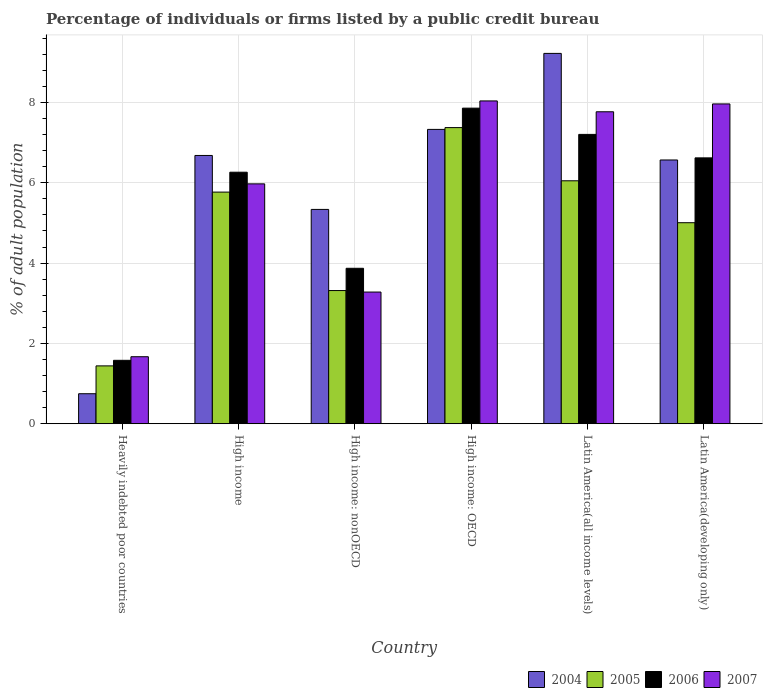How many groups of bars are there?
Provide a short and direct response. 6. Are the number of bars per tick equal to the number of legend labels?
Offer a terse response. Yes. What is the label of the 3rd group of bars from the left?
Give a very brief answer. High income: nonOECD. In how many cases, is the number of bars for a given country not equal to the number of legend labels?
Your answer should be very brief. 0. What is the percentage of population listed by a public credit bureau in 2004 in Heavily indebted poor countries?
Ensure brevity in your answer.  0.75. Across all countries, what is the maximum percentage of population listed by a public credit bureau in 2004?
Provide a succinct answer. 9.22. Across all countries, what is the minimum percentage of population listed by a public credit bureau in 2005?
Offer a terse response. 1.44. In which country was the percentage of population listed by a public credit bureau in 2004 maximum?
Your answer should be compact. Latin America(all income levels). In which country was the percentage of population listed by a public credit bureau in 2005 minimum?
Your answer should be very brief. Heavily indebted poor countries. What is the total percentage of population listed by a public credit bureau in 2005 in the graph?
Your answer should be very brief. 28.95. What is the difference between the percentage of population listed by a public credit bureau in 2005 in High income and that in Latin America(developing only)?
Offer a terse response. 0.76. What is the difference between the percentage of population listed by a public credit bureau in 2004 in High income: nonOECD and the percentage of population listed by a public credit bureau in 2007 in Heavily indebted poor countries?
Your answer should be compact. 3.67. What is the average percentage of population listed by a public credit bureau in 2004 per country?
Give a very brief answer. 5.98. What is the difference between the percentage of population listed by a public credit bureau of/in 2004 and percentage of population listed by a public credit bureau of/in 2007 in High income: OECD?
Your answer should be very brief. -0.71. In how many countries, is the percentage of population listed by a public credit bureau in 2007 greater than 4.4 %?
Give a very brief answer. 4. What is the ratio of the percentage of population listed by a public credit bureau in 2007 in Heavily indebted poor countries to that in High income: OECD?
Provide a succinct answer. 0.21. Is the percentage of population listed by a public credit bureau in 2005 in High income: OECD less than that in Latin America(all income levels)?
Ensure brevity in your answer.  No. Is the difference between the percentage of population listed by a public credit bureau in 2004 in Heavily indebted poor countries and High income: OECD greater than the difference between the percentage of population listed by a public credit bureau in 2007 in Heavily indebted poor countries and High income: OECD?
Ensure brevity in your answer.  No. What is the difference between the highest and the second highest percentage of population listed by a public credit bureau in 2007?
Your response must be concise. 0.27. What is the difference between the highest and the lowest percentage of population listed by a public credit bureau in 2005?
Your answer should be very brief. 5.93. What does the 2nd bar from the left in Latin America(all income levels) represents?
Provide a succinct answer. 2005. How many bars are there?
Ensure brevity in your answer.  24. How many countries are there in the graph?
Offer a very short reply. 6. Are the values on the major ticks of Y-axis written in scientific E-notation?
Your answer should be compact. No. Where does the legend appear in the graph?
Offer a very short reply. Bottom right. How are the legend labels stacked?
Keep it short and to the point. Horizontal. What is the title of the graph?
Your response must be concise. Percentage of individuals or firms listed by a public credit bureau. What is the label or title of the X-axis?
Your response must be concise. Country. What is the label or title of the Y-axis?
Give a very brief answer. % of adult population. What is the % of adult population of 2004 in Heavily indebted poor countries?
Give a very brief answer. 0.75. What is the % of adult population of 2005 in Heavily indebted poor countries?
Offer a terse response. 1.44. What is the % of adult population of 2006 in Heavily indebted poor countries?
Your answer should be very brief. 1.58. What is the % of adult population of 2007 in Heavily indebted poor countries?
Offer a very short reply. 1.67. What is the % of adult population of 2004 in High income?
Keep it short and to the point. 6.68. What is the % of adult population in 2005 in High income?
Your response must be concise. 5.77. What is the % of adult population in 2006 in High income?
Your answer should be very brief. 6.26. What is the % of adult population of 2007 in High income?
Your answer should be very brief. 5.97. What is the % of adult population of 2004 in High income: nonOECD?
Provide a succinct answer. 5.34. What is the % of adult population in 2005 in High income: nonOECD?
Provide a succinct answer. 3.32. What is the % of adult population in 2006 in High income: nonOECD?
Offer a very short reply. 3.87. What is the % of adult population in 2007 in High income: nonOECD?
Your response must be concise. 3.28. What is the % of adult population of 2004 in High income: OECD?
Your response must be concise. 7.33. What is the % of adult population in 2005 in High income: OECD?
Your answer should be very brief. 7.37. What is the % of adult population of 2006 in High income: OECD?
Provide a succinct answer. 7.86. What is the % of adult population of 2007 in High income: OECD?
Ensure brevity in your answer.  8.04. What is the % of adult population of 2004 in Latin America(all income levels)?
Give a very brief answer. 9.22. What is the % of adult population of 2005 in Latin America(all income levels)?
Offer a terse response. 6.05. What is the % of adult population of 2006 in Latin America(all income levels)?
Your response must be concise. 7.2. What is the % of adult population in 2007 in Latin America(all income levels)?
Provide a succinct answer. 7.77. What is the % of adult population of 2004 in Latin America(developing only)?
Offer a terse response. 6.57. What is the % of adult population of 2005 in Latin America(developing only)?
Your response must be concise. 5. What is the % of adult population in 2006 in Latin America(developing only)?
Your response must be concise. 6.62. What is the % of adult population in 2007 in Latin America(developing only)?
Your answer should be very brief. 7.96. Across all countries, what is the maximum % of adult population of 2004?
Ensure brevity in your answer.  9.22. Across all countries, what is the maximum % of adult population in 2005?
Provide a short and direct response. 7.37. Across all countries, what is the maximum % of adult population of 2006?
Provide a succinct answer. 7.86. Across all countries, what is the maximum % of adult population of 2007?
Provide a short and direct response. 8.04. Across all countries, what is the minimum % of adult population of 2004?
Ensure brevity in your answer.  0.75. Across all countries, what is the minimum % of adult population of 2005?
Your answer should be very brief. 1.44. Across all countries, what is the minimum % of adult population of 2006?
Your answer should be compact. 1.58. Across all countries, what is the minimum % of adult population in 2007?
Keep it short and to the point. 1.67. What is the total % of adult population of 2004 in the graph?
Give a very brief answer. 35.88. What is the total % of adult population in 2005 in the graph?
Provide a short and direct response. 28.95. What is the total % of adult population of 2006 in the graph?
Offer a terse response. 33.39. What is the total % of adult population in 2007 in the graph?
Offer a very short reply. 34.68. What is the difference between the % of adult population in 2004 in Heavily indebted poor countries and that in High income?
Ensure brevity in your answer.  -5.93. What is the difference between the % of adult population of 2005 in Heavily indebted poor countries and that in High income?
Your answer should be very brief. -4.33. What is the difference between the % of adult population in 2006 in Heavily indebted poor countries and that in High income?
Provide a short and direct response. -4.68. What is the difference between the % of adult population of 2007 in Heavily indebted poor countries and that in High income?
Your response must be concise. -4.3. What is the difference between the % of adult population in 2004 in Heavily indebted poor countries and that in High income: nonOECD?
Provide a succinct answer. -4.59. What is the difference between the % of adult population in 2005 in Heavily indebted poor countries and that in High income: nonOECD?
Provide a succinct answer. -1.88. What is the difference between the % of adult population of 2006 in Heavily indebted poor countries and that in High income: nonOECD?
Your response must be concise. -2.29. What is the difference between the % of adult population of 2007 in Heavily indebted poor countries and that in High income: nonOECD?
Ensure brevity in your answer.  -1.61. What is the difference between the % of adult population of 2004 in Heavily indebted poor countries and that in High income: OECD?
Keep it short and to the point. -6.58. What is the difference between the % of adult population in 2005 in Heavily indebted poor countries and that in High income: OECD?
Offer a very short reply. -5.93. What is the difference between the % of adult population of 2006 in Heavily indebted poor countries and that in High income: OECD?
Give a very brief answer. -6.28. What is the difference between the % of adult population in 2007 in Heavily indebted poor countries and that in High income: OECD?
Give a very brief answer. -6.37. What is the difference between the % of adult population of 2004 in Heavily indebted poor countries and that in Latin America(all income levels)?
Make the answer very short. -8.47. What is the difference between the % of adult population in 2005 in Heavily indebted poor countries and that in Latin America(all income levels)?
Give a very brief answer. -4.61. What is the difference between the % of adult population in 2006 in Heavily indebted poor countries and that in Latin America(all income levels)?
Your answer should be compact. -5.62. What is the difference between the % of adult population in 2007 in Heavily indebted poor countries and that in Latin America(all income levels)?
Offer a very short reply. -6.1. What is the difference between the % of adult population in 2004 in Heavily indebted poor countries and that in Latin America(developing only)?
Provide a succinct answer. -5.82. What is the difference between the % of adult population in 2005 in Heavily indebted poor countries and that in Latin America(developing only)?
Make the answer very short. -3.56. What is the difference between the % of adult population in 2006 in Heavily indebted poor countries and that in Latin America(developing only)?
Keep it short and to the point. -5.04. What is the difference between the % of adult population of 2007 in Heavily indebted poor countries and that in Latin America(developing only)?
Your answer should be compact. -6.29. What is the difference between the % of adult population in 2004 in High income and that in High income: nonOECD?
Ensure brevity in your answer.  1.34. What is the difference between the % of adult population of 2005 in High income and that in High income: nonOECD?
Your answer should be very brief. 2.45. What is the difference between the % of adult population in 2006 in High income and that in High income: nonOECD?
Provide a succinct answer. 2.39. What is the difference between the % of adult population of 2007 in High income and that in High income: nonOECD?
Make the answer very short. 2.69. What is the difference between the % of adult population of 2004 in High income and that in High income: OECD?
Offer a very short reply. -0.65. What is the difference between the % of adult population in 2005 in High income and that in High income: OECD?
Provide a short and direct response. -1.61. What is the difference between the % of adult population of 2006 in High income and that in High income: OECD?
Give a very brief answer. -1.59. What is the difference between the % of adult population of 2007 in High income and that in High income: OECD?
Ensure brevity in your answer.  -2.06. What is the difference between the % of adult population in 2004 in High income and that in Latin America(all income levels)?
Keep it short and to the point. -2.54. What is the difference between the % of adult population in 2005 in High income and that in Latin America(all income levels)?
Give a very brief answer. -0.28. What is the difference between the % of adult population in 2006 in High income and that in Latin America(all income levels)?
Make the answer very short. -0.94. What is the difference between the % of adult population of 2007 in High income and that in Latin America(all income levels)?
Keep it short and to the point. -1.79. What is the difference between the % of adult population of 2004 in High income and that in Latin America(developing only)?
Provide a short and direct response. 0.11. What is the difference between the % of adult population in 2005 in High income and that in Latin America(developing only)?
Offer a very short reply. 0.76. What is the difference between the % of adult population of 2006 in High income and that in Latin America(developing only)?
Offer a very short reply. -0.36. What is the difference between the % of adult population of 2007 in High income and that in Latin America(developing only)?
Your response must be concise. -1.99. What is the difference between the % of adult population of 2004 in High income: nonOECD and that in High income: OECD?
Your response must be concise. -1.99. What is the difference between the % of adult population of 2005 in High income: nonOECD and that in High income: OECD?
Your response must be concise. -4.06. What is the difference between the % of adult population of 2006 in High income: nonOECD and that in High income: OECD?
Your answer should be compact. -3.99. What is the difference between the % of adult population in 2007 in High income: nonOECD and that in High income: OECD?
Offer a very short reply. -4.76. What is the difference between the % of adult population of 2004 in High income: nonOECD and that in Latin America(all income levels)?
Your answer should be compact. -3.88. What is the difference between the % of adult population of 2005 in High income: nonOECD and that in Latin America(all income levels)?
Offer a terse response. -2.73. What is the difference between the % of adult population of 2006 in High income: nonOECD and that in Latin America(all income levels)?
Provide a short and direct response. -3.33. What is the difference between the % of adult population in 2007 in High income: nonOECD and that in Latin America(all income levels)?
Offer a very short reply. -4.49. What is the difference between the % of adult population in 2004 in High income: nonOECD and that in Latin America(developing only)?
Keep it short and to the point. -1.23. What is the difference between the % of adult population of 2005 in High income: nonOECD and that in Latin America(developing only)?
Keep it short and to the point. -1.69. What is the difference between the % of adult population in 2006 in High income: nonOECD and that in Latin America(developing only)?
Keep it short and to the point. -2.75. What is the difference between the % of adult population in 2007 in High income: nonOECD and that in Latin America(developing only)?
Provide a succinct answer. -4.68. What is the difference between the % of adult population of 2004 in High income: OECD and that in Latin America(all income levels)?
Your answer should be compact. -1.89. What is the difference between the % of adult population in 2005 in High income: OECD and that in Latin America(all income levels)?
Give a very brief answer. 1.32. What is the difference between the % of adult population in 2006 in High income: OECD and that in Latin America(all income levels)?
Provide a succinct answer. 0.65. What is the difference between the % of adult population of 2007 in High income: OECD and that in Latin America(all income levels)?
Give a very brief answer. 0.27. What is the difference between the % of adult population of 2004 in High income: OECD and that in Latin America(developing only)?
Your answer should be compact. 0.76. What is the difference between the % of adult population in 2005 in High income: OECD and that in Latin America(developing only)?
Your answer should be compact. 2.37. What is the difference between the % of adult population of 2006 in High income: OECD and that in Latin America(developing only)?
Your answer should be compact. 1.24. What is the difference between the % of adult population in 2007 in High income: OECD and that in Latin America(developing only)?
Your answer should be compact. 0.07. What is the difference between the % of adult population of 2004 in Latin America(all income levels) and that in Latin America(developing only)?
Your answer should be very brief. 2.65. What is the difference between the % of adult population in 2005 in Latin America(all income levels) and that in Latin America(developing only)?
Offer a very short reply. 1.04. What is the difference between the % of adult population of 2006 in Latin America(all income levels) and that in Latin America(developing only)?
Ensure brevity in your answer.  0.58. What is the difference between the % of adult population in 2007 in Latin America(all income levels) and that in Latin America(developing only)?
Offer a terse response. -0.2. What is the difference between the % of adult population in 2004 in Heavily indebted poor countries and the % of adult population in 2005 in High income?
Offer a very short reply. -5.02. What is the difference between the % of adult population of 2004 in Heavily indebted poor countries and the % of adult population of 2006 in High income?
Keep it short and to the point. -5.51. What is the difference between the % of adult population in 2004 in Heavily indebted poor countries and the % of adult population in 2007 in High income?
Provide a succinct answer. -5.22. What is the difference between the % of adult population of 2005 in Heavily indebted poor countries and the % of adult population of 2006 in High income?
Your answer should be very brief. -4.82. What is the difference between the % of adult population in 2005 in Heavily indebted poor countries and the % of adult population in 2007 in High income?
Ensure brevity in your answer.  -4.53. What is the difference between the % of adult population in 2006 in Heavily indebted poor countries and the % of adult population in 2007 in High income?
Give a very brief answer. -4.39. What is the difference between the % of adult population in 2004 in Heavily indebted poor countries and the % of adult population in 2005 in High income: nonOECD?
Your response must be concise. -2.57. What is the difference between the % of adult population of 2004 in Heavily indebted poor countries and the % of adult population of 2006 in High income: nonOECD?
Give a very brief answer. -3.12. What is the difference between the % of adult population in 2004 in Heavily indebted poor countries and the % of adult population in 2007 in High income: nonOECD?
Provide a short and direct response. -2.53. What is the difference between the % of adult population of 2005 in Heavily indebted poor countries and the % of adult population of 2006 in High income: nonOECD?
Keep it short and to the point. -2.43. What is the difference between the % of adult population of 2005 in Heavily indebted poor countries and the % of adult population of 2007 in High income: nonOECD?
Offer a very short reply. -1.84. What is the difference between the % of adult population of 2006 in Heavily indebted poor countries and the % of adult population of 2007 in High income: nonOECD?
Provide a short and direct response. -1.7. What is the difference between the % of adult population of 2004 in Heavily indebted poor countries and the % of adult population of 2005 in High income: OECD?
Provide a succinct answer. -6.63. What is the difference between the % of adult population of 2004 in Heavily indebted poor countries and the % of adult population of 2006 in High income: OECD?
Your response must be concise. -7.11. What is the difference between the % of adult population of 2004 in Heavily indebted poor countries and the % of adult population of 2007 in High income: OECD?
Make the answer very short. -7.29. What is the difference between the % of adult population of 2005 in Heavily indebted poor countries and the % of adult population of 2006 in High income: OECD?
Your answer should be compact. -6.42. What is the difference between the % of adult population of 2005 in Heavily indebted poor countries and the % of adult population of 2007 in High income: OECD?
Keep it short and to the point. -6.6. What is the difference between the % of adult population in 2006 in Heavily indebted poor countries and the % of adult population in 2007 in High income: OECD?
Keep it short and to the point. -6.46. What is the difference between the % of adult population of 2004 in Heavily indebted poor countries and the % of adult population of 2005 in Latin America(all income levels)?
Make the answer very short. -5.3. What is the difference between the % of adult population of 2004 in Heavily indebted poor countries and the % of adult population of 2006 in Latin America(all income levels)?
Offer a very short reply. -6.46. What is the difference between the % of adult population of 2004 in Heavily indebted poor countries and the % of adult population of 2007 in Latin America(all income levels)?
Keep it short and to the point. -7.02. What is the difference between the % of adult population in 2005 in Heavily indebted poor countries and the % of adult population in 2006 in Latin America(all income levels)?
Offer a very short reply. -5.76. What is the difference between the % of adult population in 2005 in Heavily indebted poor countries and the % of adult population in 2007 in Latin America(all income levels)?
Give a very brief answer. -6.33. What is the difference between the % of adult population in 2006 in Heavily indebted poor countries and the % of adult population in 2007 in Latin America(all income levels)?
Your response must be concise. -6.19. What is the difference between the % of adult population in 2004 in Heavily indebted poor countries and the % of adult population in 2005 in Latin America(developing only)?
Your answer should be compact. -4.26. What is the difference between the % of adult population in 2004 in Heavily indebted poor countries and the % of adult population in 2006 in Latin America(developing only)?
Offer a terse response. -5.87. What is the difference between the % of adult population of 2004 in Heavily indebted poor countries and the % of adult population of 2007 in Latin America(developing only)?
Provide a short and direct response. -7.21. What is the difference between the % of adult population of 2005 in Heavily indebted poor countries and the % of adult population of 2006 in Latin America(developing only)?
Your answer should be compact. -5.18. What is the difference between the % of adult population in 2005 in Heavily indebted poor countries and the % of adult population in 2007 in Latin America(developing only)?
Ensure brevity in your answer.  -6.52. What is the difference between the % of adult population of 2006 in Heavily indebted poor countries and the % of adult population of 2007 in Latin America(developing only)?
Make the answer very short. -6.38. What is the difference between the % of adult population of 2004 in High income and the % of adult population of 2005 in High income: nonOECD?
Offer a terse response. 3.36. What is the difference between the % of adult population in 2004 in High income and the % of adult population in 2006 in High income: nonOECD?
Ensure brevity in your answer.  2.81. What is the difference between the % of adult population of 2004 in High income and the % of adult population of 2007 in High income: nonOECD?
Ensure brevity in your answer.  3.4. What is the difference between the % of adult population of 2005 in High income and the % of adult population of 2006 in High income: nonOECD?
Your answer should be compact. 1.9. What is the difference between the % of adult population in 2005 in High income and the % of adult population in 2007 in High income: nonOECD?
Your answer should be compact. 2.49. What is the difference between the % of adult population in 2006 in High income and the % of adult population in 2007 in High income: nonOECD?
Offer a very short reply. 2.98. What is the difference between the % of adult population in 2004 in High income and the % of adult population in 2005 in High income: OECD?
Offer a very short reply. -0.69. What is the difference between the % of adult population of 2004 in High income and the % of adult population of 2006 in High income: OECD?
Your answer should be compact. -1.18. What is the difference between the % of adult population of 2004 in High income and the % of adult population of 2007 in High income: OECD?
Give a very brief answer. -1.36. What is the difference between the % of adult population of 2005 in High income and the % of adult population of 2006 in High income: OECD?
Make the answer very short. -2.09. What is the difference between the % of adult population in 2005 in High income and the % of adult population in 2007 in High income: OECD?
Offer a very short reply. -2.27. What is the difference between the % of adult population of 2006 in High income and the % of adult population of 2007 in High income: OECD?
Offer a terse response. -1.77. What is the difference between the % of adult population in 2004 in High income and the % of adult population in 2005 in Latin America(all income levels)?
Your answer should be very brief. 0.63. What is the difference between the % of adult population of 2004 in High income and the % of adult population of 2006 in Latin America(all income levels)?
Give a very brief answer. -0.52. What is the difference between the % of adult population of 2004 in High income and the % of adult population of 2007 in Latin America(all income levels)?
Provide a succinct answer. -1.09. What is the difference between the % of adult population of 2005 in High income and the % of adult population of 2006 in Latin America(all income levels)?
Your answer should be compact. -1.44. What is the difference between the % of adult population of 2006 in High income and the % of adult population of 2007 in Latin America(all income levels)?
Your response must be concise. -1.5. What is the difference between the % of adult population in 2004 in High income and the % of adult population in 2005 in Latin America(developing only)?
Offer a terse response. 1.67. What is the difference between the % of adult population in 2004 in High income and the % of adult population in 2006 in Latin America(developing only)?
Provide a succinct answer. 0.06. What is the difference between the % of adult population in 2004 in High income and the % of adult population in 2007 in Latin America(developing only)?
Make the answer very short. -1.28. What is the difference between the % of adult population of 2005 in High income and the % of adult population of 2006 in Latin America(developing only)?
Offer a very short reply. -0.85. What is the difference between the % of adult population in 2005 in High income and the % of adult population in 2007 in Latin America(developing only)?
Ensure brevity in your answer.  -2.2. What is the difference between the % of adult population of 2006 in High income and the % of adult population of 2007 in Latin America(developing only)?
Offer a terse response. -1.7. What is the difference between the % of adult population of 2004 in High income: nonOECD and the % of adult population of 2005 in High income: OECD?
Offer a very short reply. -2.04. What is the difference between the % of adult population of 2004 in High income: nonOECD and the % of adult population of 2006 in High income: OECD?
Provide a short and direct response. -2.52. What is the difference between the % of adult population in 2004 in High income: nonOECD and the % of adult population in 2007 in High income: OECD?
Give a very brief answer. -2.7. What is the difference between the % of adult population of 2005 in High income: nonOECD and the % of adult population of 2006 in High income: OECD?
Make the answer very short. -4.54. What is the difference between the % of adult population of 2005 in High income: nonOECD and the % of adult population of 2007 in High income: OECD?
Keep it short and to the point. -4.72. What is the difference between the % of adult population of 2006 in High income: nonOECD and the % of adult population of 2007 in High income: OECD?
Your answer should be very brief. -4.17. What is the difference between the % of adult population of 2004 in High income: nonOECD and the % of adult population of 2005 in Latin America(all income levels)?
Provide a short and direct response. -0.71. What is the difference between the % of adult population in 2004 in High income: nonOECD and the % of adult population in 2006 in Latin America(all income levels)?
Provide a succinct answer. -1.87. What is the difference between the % of adult population in 2004 in High income: nonOECD and the % of adult population in 2007 in Latin America(all income levels)?
Your response must be concise. -2.43. What is the difference between the % of adult population in 2005 in High income: nonOECD and the % of adult population in 2006 in Latin America(all income levels)?
Provide a succinct answer. -3.89. What is the difference between the % of adult population of 2005 in High income: nonOECD and the % of adult population of 2007 in Latin America(all income levels)?
Make the answer very short. -4.45. What is the difference between the % of adult population in 2006 in High income: nonOECD and the % of adult population in 2007 in Latin America(all income levels)?
Make the answer very short. -3.9. What is the difference between the % of adult population of 2004 in High income: nonOECD and the % of adult population of 2005 in Latin America(developing only)?
Your answer should be compact. 0.33. What is the difference between the % of adult population of 2004 in High income: nonOECD and the % of adult population of 2006 in Latin America(developing only)?
Keep it short and to the point. -1.28. What is the difference between the % of adult population in 2004 in High income: nonOECD and the % of adult population in 2007 in Latin America(developing only)?
Offer a terse response. -2.63. What is the difference between the % of adult population of 2005 in High income: nonOECD and the % of adult population of 2006 in Latin America(developing only)?
Provide a short and direct response. -3.3. What is the difference between the % of adult population in 2005 in High income: nonOECD and the % of adult population in 2007 in Latin America(developing only)?
Provide a succinct answer. -4.65. What is the difference between the % of adult population in 2006 in High income: nonOECD and the % of adult population in 2007 in Latin America(developing only)?
Keep it short and to the point. -4.09. What is the difference between the % of adult population of 2004 in High income: OECD and the % of adult population of 2005 in Latin America(all income levels)?
Provide a short and direct response. 1.28. What is the difference between the % of adult population in 2004 in High income: OECD and the % of adult population in 2006 in Latin America(all income levels)?
Provide a short and direct response. 0.12. What is the difference between the % of adult population in 2004 in High income: OECD and the % of adult population in 2007 in Latin America(all income levels)?
Offer a very short reply. -0.44. What is the difference between the % of adult population of 2005 in High income: OECD and the % of adult population of 2006 in Latin America(all income levels)?
Ensure brevity in your answer.  0.17. What is the difference between the % of adult population in 2005 in High income: OECD and the % of adult population in 2007 in Latin America(all income levels)?
Make the answer very short. -0.39. What is the difference between the % of adult population of 2006 in High income: OECD and the % of adult population of 2007 in Latin America(all income levels)?
Keep it short and to the point. 0.09. What is the difference between the % of adult population in 2004 in High income: OECD and the % of adult population in 2005 in Latin America(developing only)?
Keep it short and to the point. 2.32. What is the difference between the % of adult population of 2004 in High income: OECD and the % of adult population of 2006 in Latin America(developing only)?
Give a very brief answer. 0.71. What is the difference between the % of adult population in 2004 in High income: OECD and the % of adult population in 2007 in Latin America(developing only)?
Provide a short and direct response. -0.63. What is the difference between the % of adult population of 2005 in High income: OECD and the % of adult population of 2006 in Latin America(developing only)?
Your response must be concise. 0.75. What is the difference between the % of adult population in 2005 in High income: OECD and the % of adult population in 2007 in Latin America(developing only)?
Give a very brief answer. -0.59. What is the difference between the % of adult population of 2006 in High income: OECD and the % of adult population of 2007 in Latin America(developing only)?
Give a very brief answer. -0.11. What is the difference between the % of adult population in 2004 in Latin America(all income levels) and the % of adult population in 2005 in Latin America(developing only)?
Your answer should be very brief. 4.22. What is the difference between the % of adult population of 2004 in Latin America(all income levels) and the % of adult population of 2006 in Latin America(developing only)?
Keep it short and to the point. 2.6. What is the difference between the % of adult population in 2004 in Latin America(all income levels) and the % of adult population in 2007 in Latin America(developing only)?
Ensure brevity in your answer.  1.26. What is the difference between the % of adult population in 2005 in Latin America(all income levels) and the % of adult population in 2006 in Latin America(developing only)?
Your response must be concise. -0.57. What is the difference between the % of adult population in 2005 in Latin America(all income levels) and the % of adult population in 2007 in Latin America(developing only)?
Make the answer very short. -1.91. What is the difference between the % of adult population of 2006 in Latin America(all income levels) and the % of adult population of 2007 in Latin America(developing only)?
Your answer should be compact. -0.76. What is the average % of adult population of 2004 per country?
Provide a succinct answer. 5.98. What is the average % of adult population in 2005 per country?
Offer a very short reply. 4.82. What is the average % of adult population of 2006 per country?
Make the answer very short. 5.57. What is the average % of adult population of 2007 per country?
Ensure brevity in your answer.  5.78. What is the difference between the % of adult population of 2004 and % of adult population of 2005 in Heavily indebted poor countries?
Your response must be concise. -0.69. What is the difference between the % of adult population of 2004 and % of adult population of 2006 in Heavily indebted poor countries?
Your response must be concise. -0.83. What is the difference between the % of adult population of 2004 and % of adult population of 2007 in Heavily indebted poor countries?
Make the answer very short. -0.92. What is the difference between the % of adult population in 2005 and % of adult population in 2006 in Heavily indebted poor countries?
Offer a terse response. -0.14. What is the difference between the % of adult population in 2005 and % of adult population in 2007 in Heavily indebted poor countries?
Give a very brief answer. -0.23. What is the difference between the % of adult population in 2006 and % of adult population in 2007 in Heavily indebted poor countries?
Your response must be concise. -0.09. What is the difference between the % of adult population of 2004 and % of adult population of 2005 in High income?
Offer a very short reply. 0.91. What is the difference between the % of adult population of 2004 and % of adult population of 2006 in High income?
Your response must be concise. 0.42. What is the difference between the % of adult population in 2004 and % of adult population in 2007 in High income?
Ensure brevity in your answer.  0.71. What is the difference between the % of adult population in 2005 and % of adult population in 2006 in High income?
Provide a succinct answer. -0.5. What is the difference between the % of adult population of 2005 and % of adult population of 2007 in High income?
Offer a terse response. -0.2. What is the difference between the % of adult population of 2006 and % of adult population of 2007 in High income?
Ensure brevity in your answer.  0.29. What is the difference between the % of adult population in 2004 and % of adult population in 2005 in High income: nonOECD?
Your response must be concise. 2.02. What is the difference between the % of adult population in 2004 and % of adult population in 2006 in High income: nonOECD?
Offer a very short reply. 1.47. What is the difference between the % of adult population of 2004 and % of adult population of 2007 in High income: nonOECD?
Your response must be concise. 2.06. What is the difference between the % of adult population in 2005 and % of adult population in 2006 in High income: nonOECD?
Offer a very short reply. -0.55. What is the difference between the % of adult population in 2005 and % of adult population in 2007 in High income: nonOECD?
Keep it short and to the point. 0.04. What is the difference between the % of adult population in 2006 and % of adult population in 2007 in High income: nonOECD?
Make the answer very short. 0.59. What is the difference between the % of adult population of 2004 and % of adult population of 2005 in High income: OECD?
Ensure brevity in your answer.  -0.04. What is the difference between the % of adult population in 2004 and % of adult population in 2006 in High income: OECD?
Ensure brevity in your answer.  -0.53. What is the difference between the % of adult population in 2004 and % of adult population in 2007 in High income: OECD?
Offer a terse response. -0.71. What is the difference between the % of adult population in 2005 and % of adult population in 2006 in High income: OECD?
Your response must be concise. -0.48. What is the difference between the % of adult population in 2005 and % of adult population in 2007 in High income: OECD?
Provide a succinct answer. -0.66. What is the difference between the % of adult population in 2006 and % of adult population in 2007 in High income: OECD?
Offer a very short reply. -0.18. What is the difference between the % of adult population in 2004 and % of adult population in 2005 in Latin America(all income levels)?
Provide a short and direct response. 3.17. What is the difference between the % of adult population in 2004 and % of adult population in 2006 in Latin America(all income levels)?
Your answer should be compact. 2.02. What is the difference between the % of adult population in 2004 and % of adult population in 2007 in Latin America(all income levels)?
Make the answer very short. 1.45. What is the difference between the % of adult population in 2005 and % of adult population in 2006 in Latin America(all income levels)?
Keep it short and to the point. -1.16. What is the difference between the % of adult population of 2005 and % of adult population of 2007 in Latin America(all income levels)?
Make the answer very short. -1.72. What is the difference between the % of adult population in 2006 and % of adult population in 2007 in Latin America(all income levels)?
Give a very brief answer. -0.56. What is the difference between the % of adult population of 2004 and % of adult population of 2005 in Latin America(developing only)?
Give a very brief answer. 1.56. What is the difference between the % of adult population in 2004 and % of adult population in 2006 in Latin America(developing only)?
Offer a terse response. -0.05. What is the difference between the % of adult population in 2004 and % of adult population in 2007 in Latin America(developing only)?
Your answer should be compact. -1.4. What is the difference between the % of adult population in 2005 and % of adult population in 2006 in Latin America(developing only)?
Offer a very short reply. -1.61. What is the difference between the % of adult population of 2005 and % of adult population of 2007 in Latin America(developing only)?
Keep it short and to the point. -2.96. What is the difference between the % of adult population in 2006 and % of adult population in 2007 in Latin America(developing only)?
Your answer should be compact. -1.34. What is the ratio of the % of adult population of 2004 in Heavily indebted poor countries to that in High income?
Offer a terse response. 0.11. What is the ratio of the % of adult population of 2005 in Heavily indebted poor countries to that in High income?
Your answer should be very brief. 0.25. What is the ratio of the % of adult population of 2006 in Heavily indebted poor countries to that in High income?
Provide a succinct answer. 0.25. What is the ratio of the % of adult population of 2007 in Heavily indebted poor countries to that in High income?
Offer a very short reply. 0.28. What is the ratio of the % of adult population in 2004 in Heavily indebted poor countries to that in High income: nonOECD?
Keep it short and to the point. 0.14. What is the ratio of the % of adult population in 2005 in Heavily indebted poor countries to that in High income: nonOECD?
Provide a short and direct response. 0.43. What is the ratio of the % of adult population of 2006 in Heavily indebted poor countries to that in High income: nonOECD?
Provide a succinct answer. 0.41. What is the ratio of the % of adult population in 2007 in Heavily indebted poor countries to that in High income: nonOECD?
Your answer should be very brief. 0.51. What is the ratio of the % of adult population of 2004 in Heavily indebted poor countries to that in High income: OECD?
Your answer should be very brief. 0.1. What is the ratio of the % of adult population in 2005 in Heavily indebted poor countries to that in High income: OECD?
Your answer should be compact. 0.2. What is the ratio of the % of adult population in 2006 in Heavily indebted poor countries to that in High income: OECD?
Keep it short and to the point. 0.2. What is the ratio of the % of adult population in 2007 in Heavily indebted poor countries to that in High income: OECD?
Provide a short and direct response. 0.21. What is the ratio of the % of adult population of 2004 in Heavily indebted poor countries to that in Latin America(all income levels)?
Provide a short and direct response. 0.08. What is the ratio of the % of adult population in 2005 in Heavily indebted poor countries to that in Latin America(all income levels)?
Ensure brevity in your answer.  0.24. What is the ratio of the % of adult population in 2006 in Heavily indebted poor countries to that in Latin America(all income levels)?
Ensure brevity in your answer.  0.22. What is the ratio of the % of adult population in 2007 in Heavily indebted poor countries to that in Latin America(all income levels)?
Keep it short and to the point. 0.21. What is the ratio of the % of adult population of 2004 in Heavily indebted poor countries to that in Latin America(developing only)?
Provide a short and direct response. 0.11. What is the ratio of the % of adult population in 2005 in Heavily indebted poor countries to that in Latin America(developing only)?
Provide a short and direct response. 0.29. What is the ratio of the % of adult population of 2006 in Heavily indebted poor countries to that in Latin America(developing only)?
Your response must be concise. 0.24. What is the ratio of the % of adult population of 2007 in Heavily indebted poor countries to that in Latin America(developing only)?
Make the answer very short. 0.21. What is the ratio of the % of adult population in 2004 in High income to that in High income: nonOECD?
Ensure brevity in your answer.  1.25. What is the ratio of the % of adult population in 2005 in High income to that in High income: nonOECD?
Your answer should be compact. 1.74. What is the ratio of the % of adult population in 2006 in High income to that in High income: nonOECD?
Offer a very short reply. 1.62. What is the ratio of the % of adult population in 2007 in High income to that in High income: nonOECD?
Your answer should be compact. 1.82. What is the ratio of the % of adult population of 2004 in High income to that in High income: OECD?
Keep it short and to the point. 0.91. What is the ratio of the % of adult population of 2005 in High income to that in High income: OECD?
Make the answer very short. 0.78. What is the ratio of the % of adult population of 2006 in High income to that in High income: OECD?
Ensure brevity in your answer.  0.8. What is the ratio of the % of adult population in 2007 in High income to that in High income: OECD?
Keep it short and to the point. 0.74. What is the ratio of the % of adult population in 2004 in High income to that in Latin America(all income levels)?
Your answer should be compact. 0.72. What is the ratio of the % of adult population in 2005 in High income to that in Latin America(all income levels)?
Keep it short and to the point. 0.95. What is the ratio of the % of adult population of 2006 in High income to that in Latin America(all income levels)?
Provide a succinct answer. 0.87. What is the ratio of the % of adult population of 2007 in High income to that in Latin America(all income levels)?
Provide a short and direct response. 0.77. What is the ratio of the % of adult population of 2004 in High income to that in Latin America(developing only)?
Offer a very short reply. 1.02. What is the ratio of the % of adult population of 2005 in High income to that in Latin America(developing only)?
Keep it short and to the point. 1.15. What is the ratio of the % of adult population in 2006 in High income to that in Latin America(developing only)?
Give a very brief answer. 0.95. What is the ratio of the % of adult population of 2007 in High income to that in Latin America(developing only)?
Make the answer very short. 0.75. What is the ratio of the % of adult population in 2004 in High income: nonOECD to that in High income: OECD?
Offer a very short reply. 0.73. What is the ratio of the % of adult population of 2005 in High income: nonOECD to that in High income: OECD?
Make the answer very short. 0.45. What is the ratio of the % of adult population of 2006 in High income: nonOECD to that in High income: OECD?
Your answer should be compact. 0.49. What is the ratio of the % of adult population of 2007 in High income: nonOECD to that in High income: OECD?
Provide a short and direct response. 0.41. What is the ratio of the % of adult population in 2004 in High income: nonOECD to that in Latin America(all income levels)?
Keep it short and to the point. 0.58. What is the ratio of the % of adult population in 2005 in High income: nonOECD to that in Latin America(all income levels)?
Make the answer very short. 0.55. What is the ratio of the % of adult population in 2006 in High income: nonOECD to that in Latin America(all income levels)?
Offer a terse response. 0.54. What is the ratio of the % of adult population in 2007 in High income: nonOECD to that in Latin America(all income levels)?
Give a very brief answer. 0.42. What is the ratio of the % of adult population in 2004 in High income: nonOECD to that in Latin America(developing only)?
Your response must be concise. 0.81. What is the ratio of the % of adult population of 2005 in High income: nonOECD to that in Latin America(developing only)?
Keep it short and to the point. 0.66. What is the ratio of the % of adult population in 2006 in High income: nonOECD to that in Latin America(developing only)?
Your answer should be compact. 0.58. What is the ratio of the % of adult population of 2007 in High income: nonOECD to that in Latin America(developing only)?
Ensure brevity in your answer.  0.41. What is the ratio of the % of adult population of 2004 in High income: OECD to that in Latin America(all income levels)?
Provide a succinct answer. 0.79. What is the ratio of the % of adult population in 2005 in High income: OECD to that in Latin America(all income levels)?
Your answer should be compact. 1.22. What is the ratio of the % of adult population in 2006 in High income: OECD to that in Latin America(all income levels)?
Your answer should be compact. 1.09. What is the ratio of the % of adult population in 2007 in High income: OECD to that in Latin America(all income levels)?
Offer a very short reply. 1.03. What is the ratio of the % of adult population of 2004 in High income: OECD to that in Latin America(developing only)?
Offer a very short reply. 1.12. What is the ratio of the % of adult population in 2005 in High income: OECD to that in Latin America(developing only)?
Give a very brief answer. 1.47. What is the ratio of the % of adult population of 2006 in High income: OECD to that in Latin America(developing only)?
Your answer should be very brief. 1.19. What is the ratio of the % of adult population of 2007 in High income: OECD to that in Latin America(developing only)?
Provide a short and direct response. 1.01. What is the ratio of the % of adult population of 2004 in Latin America(all income levels) to that in Latin America(developing only)?
Offer a terse response. 1.4. What is the ratio of the % of adult population of 2005 in Latin America(all income levels) to that in Latin America(developing only)?
Make the answer very short. 1.21. What is the ratio of the % of adult population in 2006 in Latin America(all income levels) to that in Latin America(developing only)?
Provide a short and direct response. 1.09. What is the ratio of the % of adult population in 2007 in Latin America(all income levels) to that in Latin America(developing only)?
Offer a very short reply. 0.98. What is the difference between the highest and the second highest % of adult population in 2004?
Make the answer very short. 1.89. What is the difference between the highest and the second highest % of adult population of 2005?
Provide a succinct answer. 1.32. What is the difference between the highest and the second highest % of adult population in 2006?
Offer a very short reply. 0.65. What is the difference between the highest and the second highest % of adult population of 2007?
Your answer should be compact. 0.07. What is the difference between the highest and the lowest % of adult population in 2004?
Provide a succinct answer. 8.47. What is the difference between the highest and the lowest % of adult population of 2005?
Keep it short and to the point. 5.93. What is the difference between the highest and the lowest % of adult population of 2006?
Ensure brevity in your answer.  6.28. What is the difference between the highest and the lowest % of adult population of 2007?
Keep it short and to the point. 6.37. 